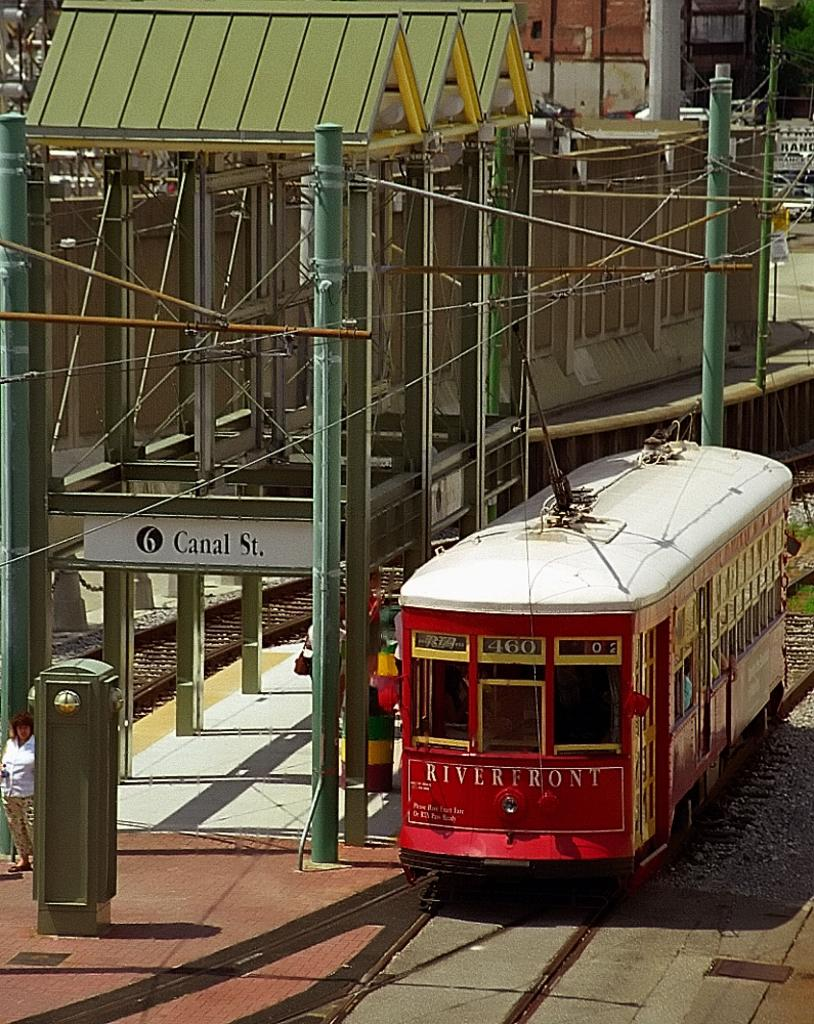What is the main subject of the image? The main subject of the image is a locomotive on the track. What else can be seen in the image besides the locomotive? There are persons standing on the floor, grills, electric cables, a name board, trees, and stones visible in the image. What type of stocking is the stranger wearing in the image? There is no stranger present in the image, so it is not possible to determine what type of stocking they might be wearing. What liquid is being poured from the grills in the image? There is no liquid being poured from the grills in the image; the grills are stationary objects. 